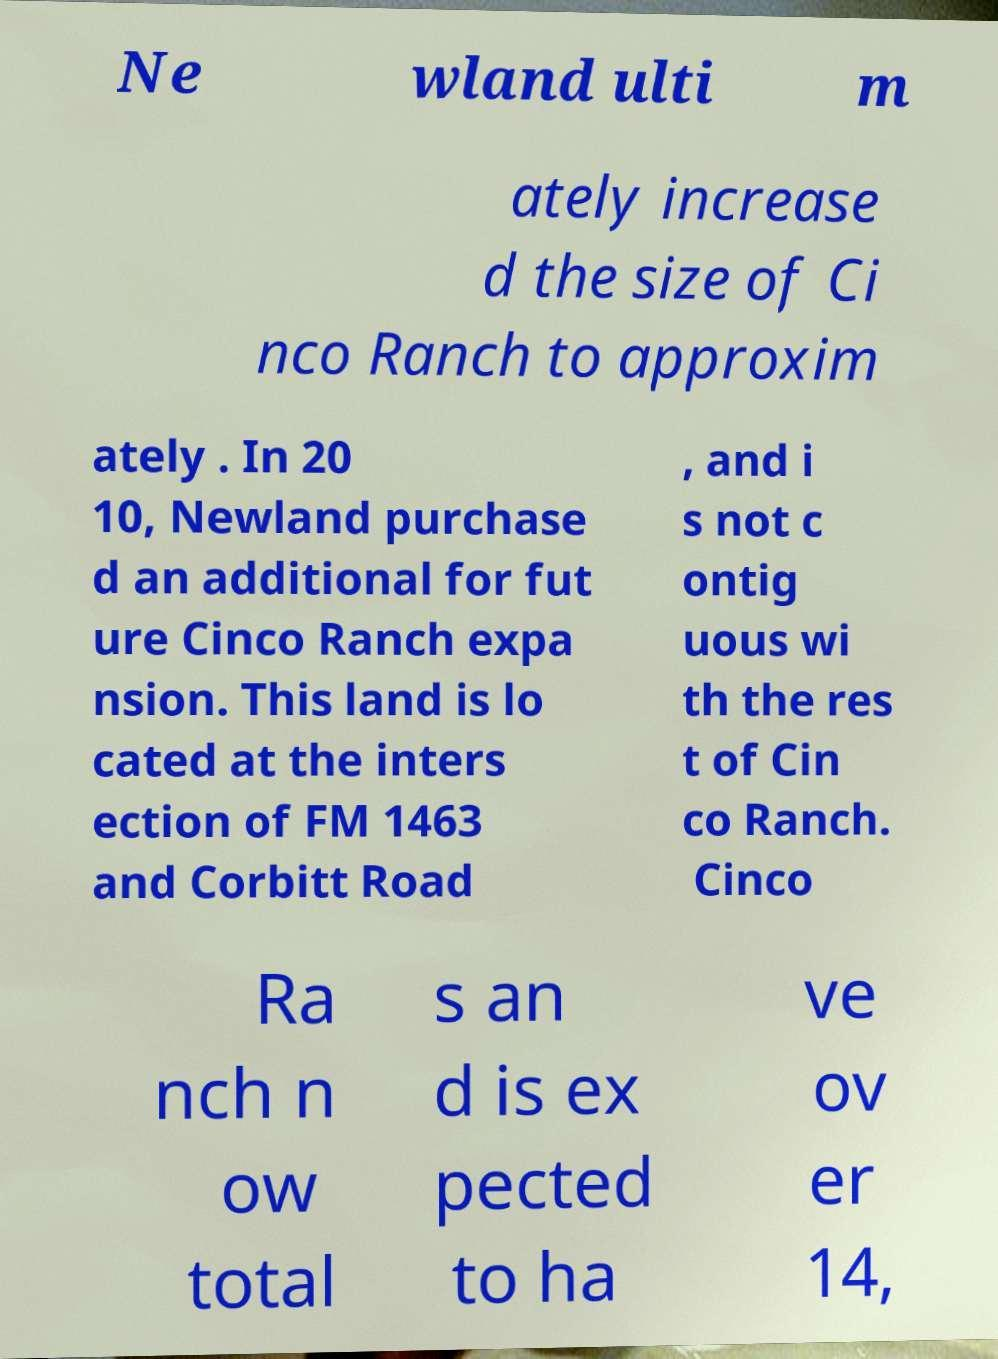There's text embedded in this image that I need extracted. Can you transcribe it verbatim? Ne wland ulti m ately increase d the size of Ci nco Ranch to approxim ately . In 20 10, Newland purchase d an additional for fut ure Cinco Ranch expa nsion. This land is lo cated at the inters ection of FM 1463 and Corbitt Road , and i s not c ontig uous wi th the res t of Cin co Ranch. Cinco Ra nch n ow total s an d is ex pected to ha ve ov er 14, 